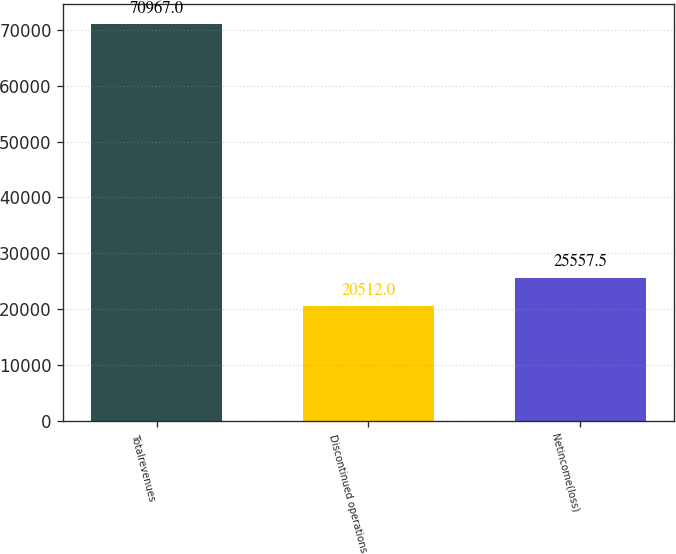Convert chart to OTSL. <chart><loc_0><loc_0><loc_500><loc_500><bar_chart><fcel>Totalrevenues<fcel>Discontinued operations<fcel>Netincome(loss)<nl><fcel>70967<fcel>20512<fcel>25557.5<nl></chart> 